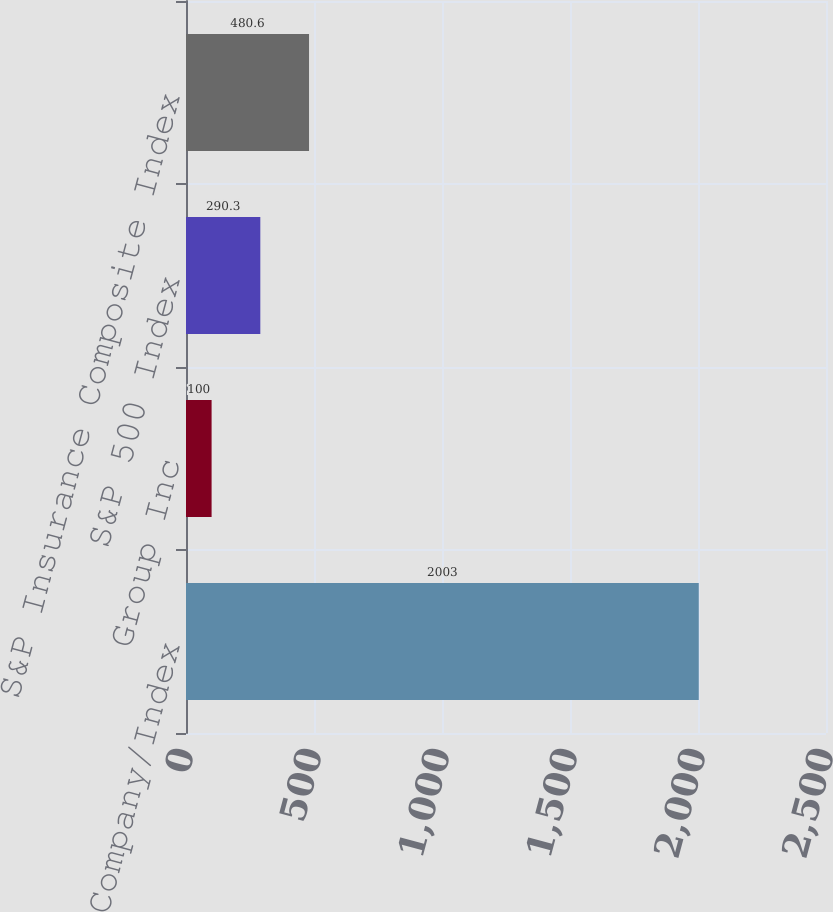Convert chart. <chart><loc_0><loc_0><loc_500><loc_500><bar_chart><fcel>Company/Index<fcel>Group Inc<fcel>S&P 500 Index<fcel>S&P Insurance Composite Index<nl><fcel>2003<fcel>100<fcel>290.3<fcel>480.6<nl></chart> 